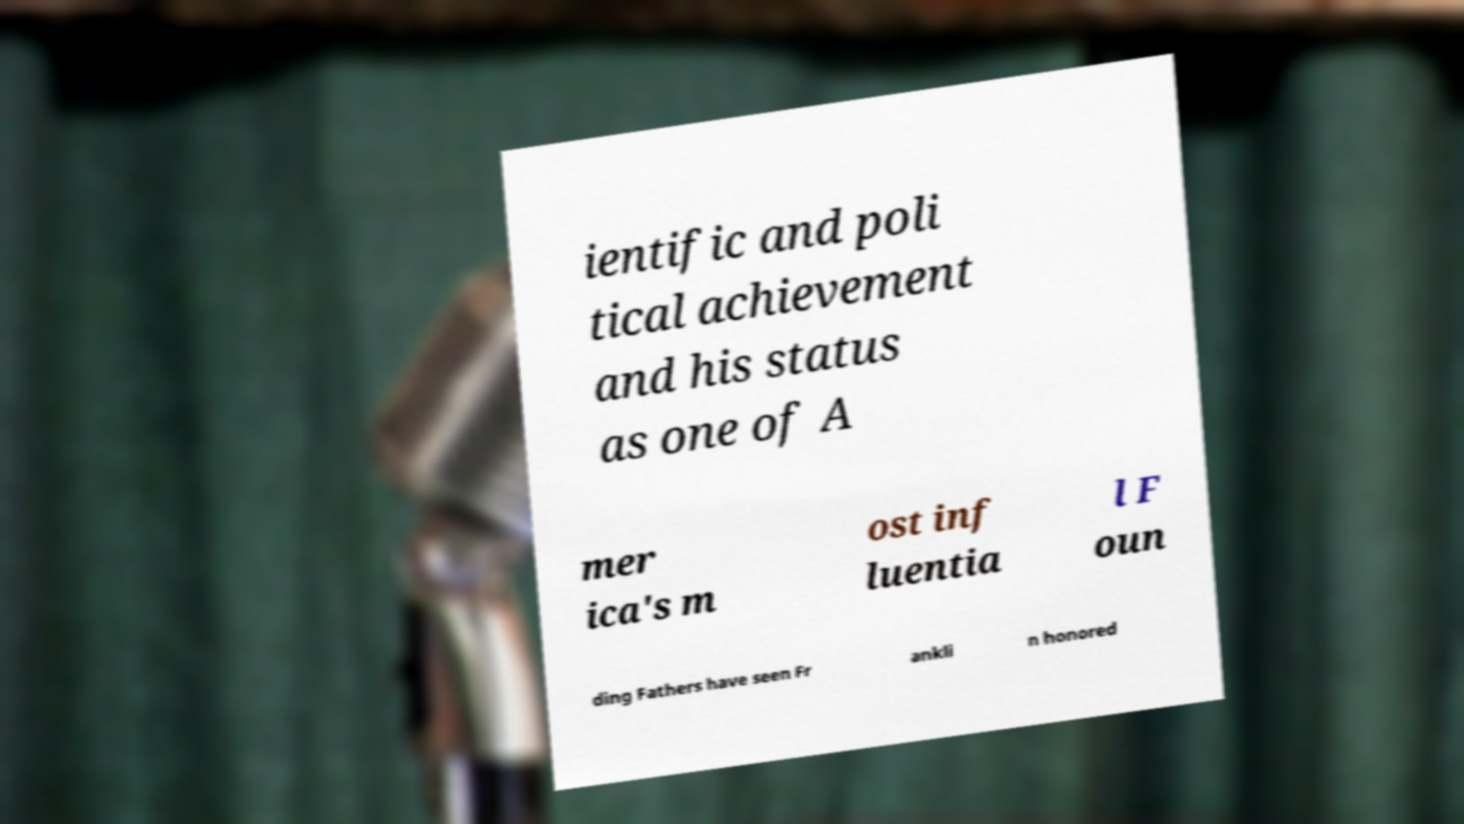For documentation purposes, I need the text within this image transcribed. Could you provide that? ientific and poli tical achievement and his status as one of A mer ica's m ost inf luentia l F oun ding Fathers have seen Fr ankli n honored 